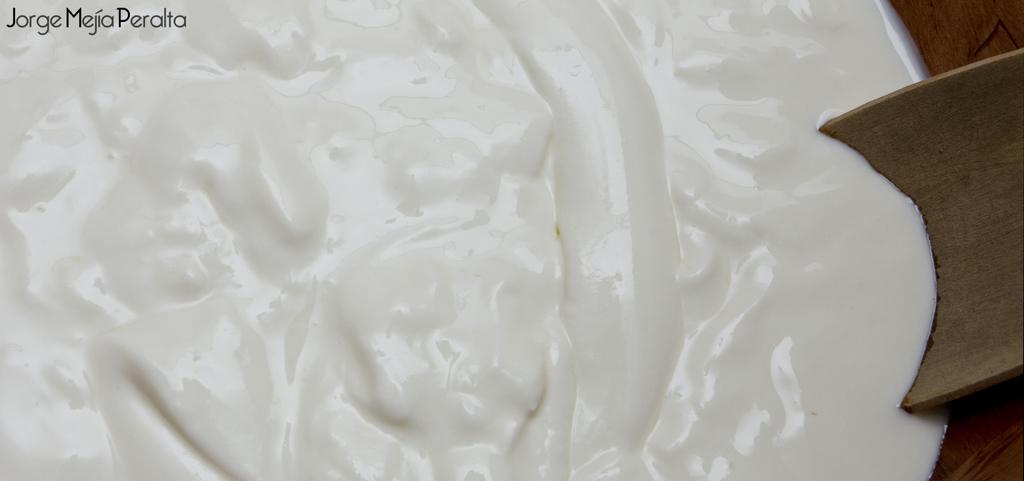What is the color of the main object in the image? There is a white color thing in the image. What is the color of the other objects in the image? There are brown color things in the image. Where is the watermark located in the image? The watermark is on the left top of the image. What type of writing can be seen on the sofa in the image? There is no sofa or writing present in the image. What is the answer to the question asked in the image? There is no question or answer present in the image. 